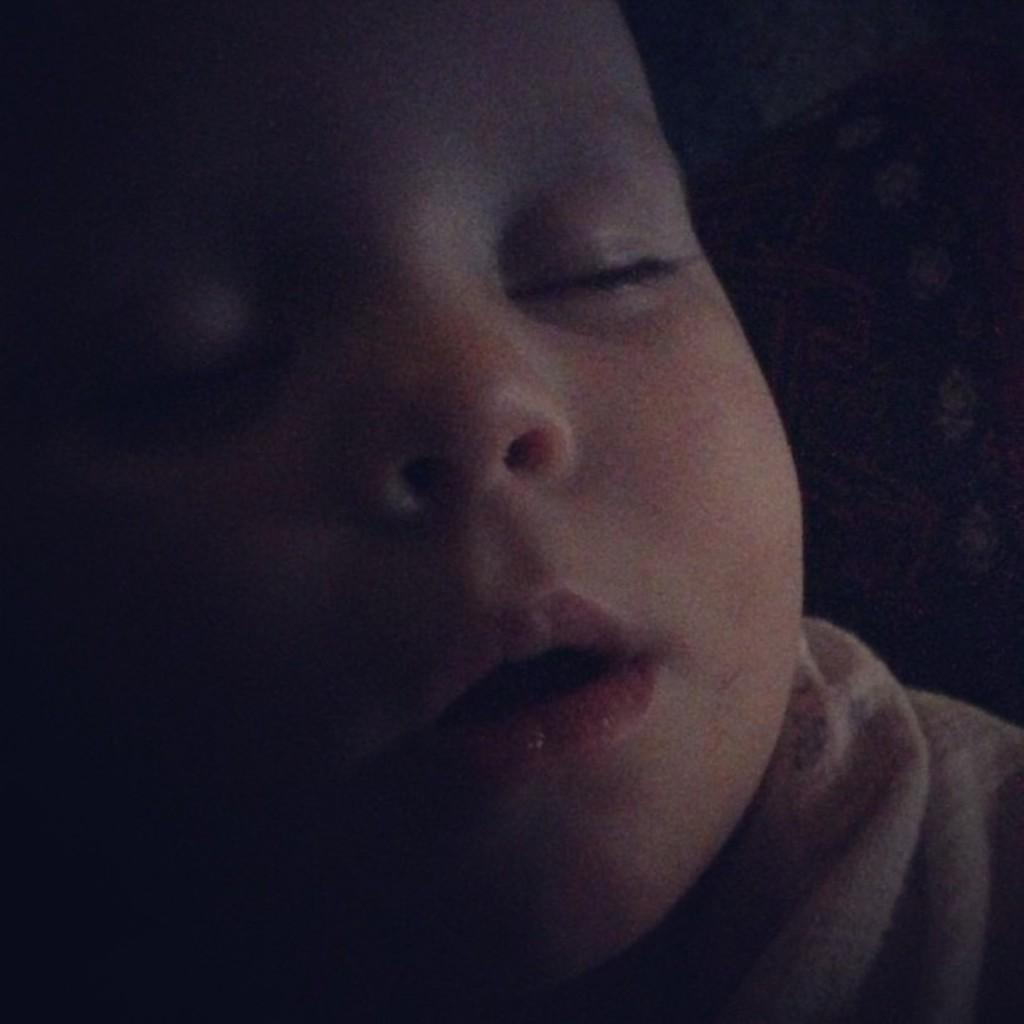What is the main subject of the image? The main subject of the image is a kid. What can be observed about the background of the image? The background of the image is dark. How many ears of corn are visible in the image? There are no ears of corn present in the image. What is the relationship between the two kids in the image? There is only one kid present in the image, so there are no brothers depicted. 